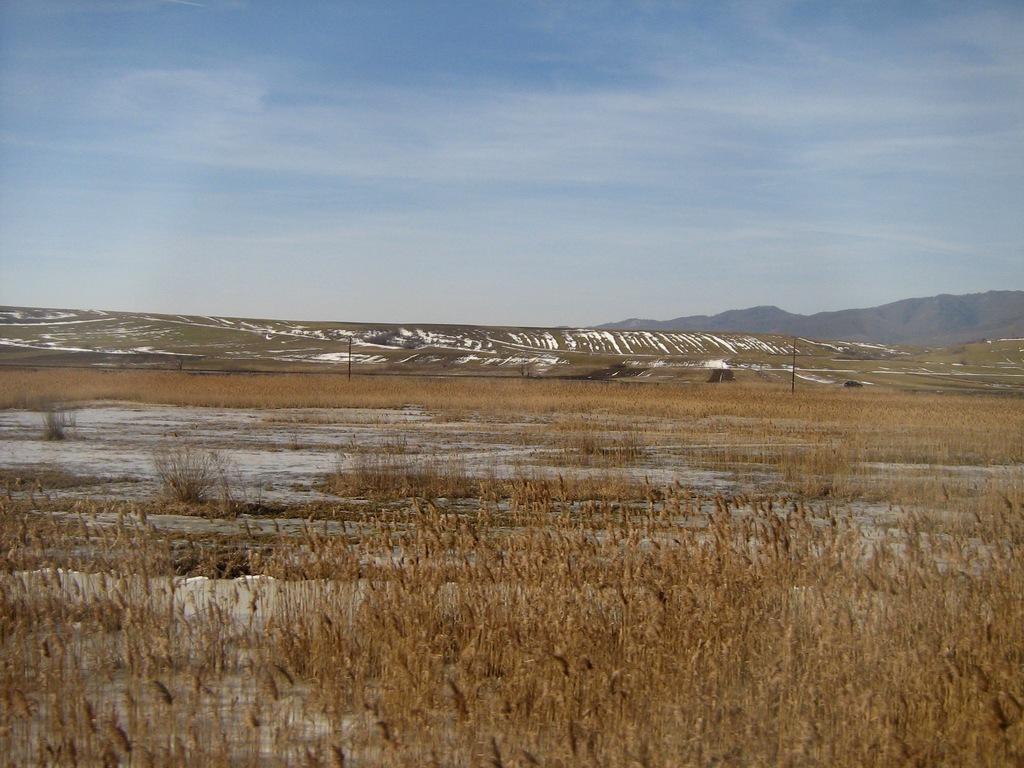What type of vegetation is present on the ground in the image? There are plants on the ground in the image. What can be seen in the background of the image? There are poles and hills visible in the background of the image. What is the weather like in the image? The presence of snow suggests that it is cold or wintry in the image. What is visible at the top of the image? The sky is visible at the top of the image. Can you see a monkey writing a letter on the hill in the image? There is no monkey or letter-writing activity present in the image; it features plants, poles, hills, snow, and a visible sky. 